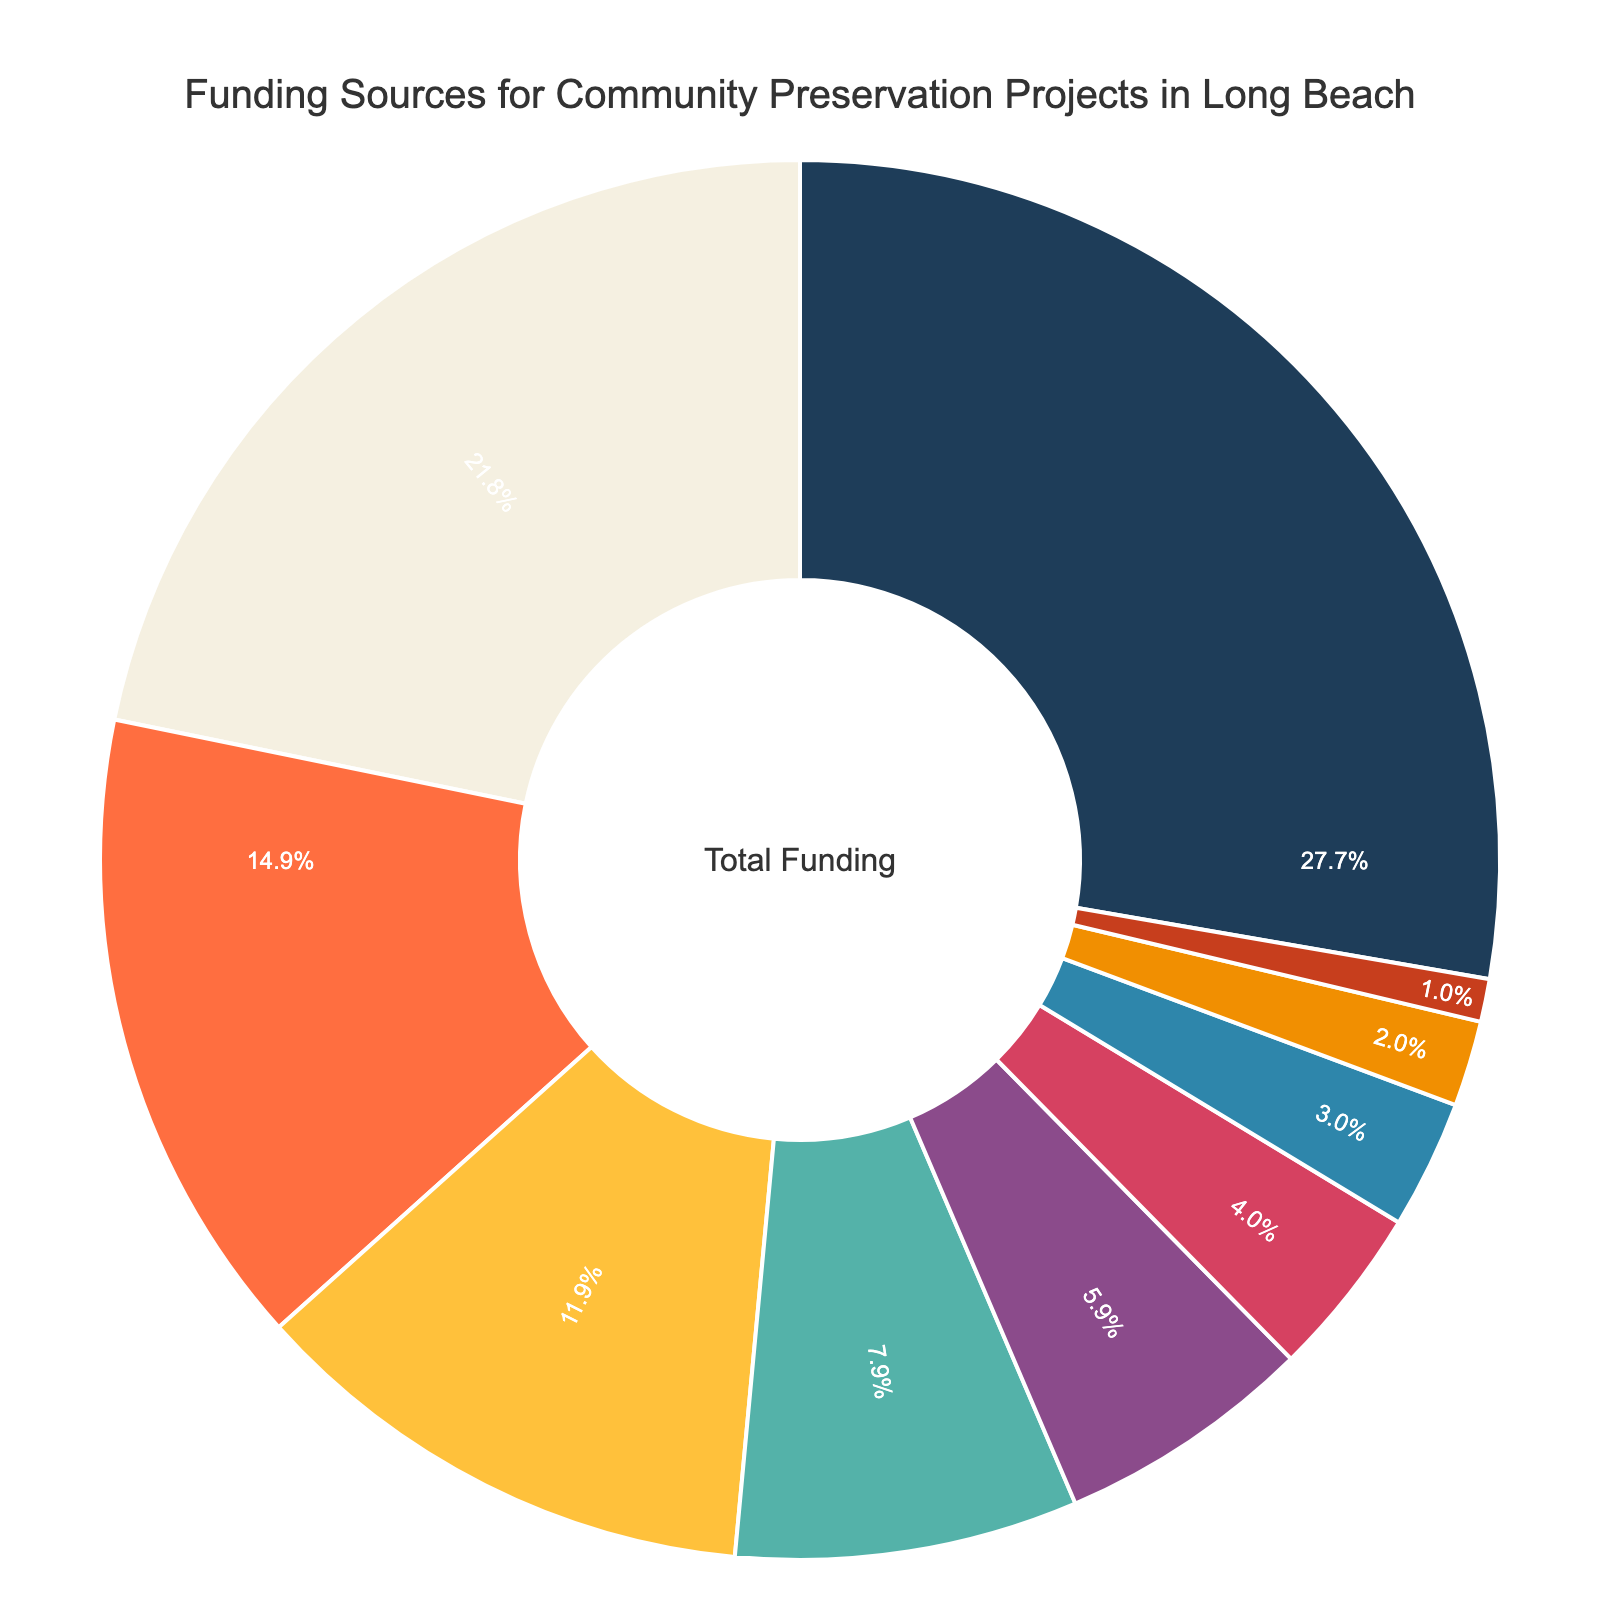Which category provides the largest portion of funding? The largest portion of the funding comes from the category with the highest percentage in the pie chart. "City Grants" has the largest portion at 28%.
Answer: City Grants What is the combined percentage of funding from Private Donations and Local Business Sponsorships? Add the percentages of Private Donations (12%) and Local Business Sponsorships (8%). The combined percentage is 12% + 8% = 20%.
Answer: 20% Which funding source contributes the least? The smallest portion of the funding is the category with the lowest percentage. "Real Estate Transfer Fees" has the smallest portion at 1%.
Answer: Real Estate Transfer Fees How much more funding do City Grants provide compared to Federal Historic Preservation Tax Credits? Subtract the percentage of Federal Historic Preservation Tax Credits (15%) from the percentage of City Grants (28%). The difference is 28% - 15% = 13%.
Answer: 13% What is the percentage contribution of crowdfunding campaigns? The percentage contribution of Crowdfunding Campaigns is directly given in the pie chart as 6%.
Answer: 6% How do State Historic Preservation Funds compare to Private Donations in terms of percentage? Compare the percentages: State Historic Preservation Funds (22%) vs. Private Donations (12%). State Historic Preservation Funds contribute a higher percentage.
Answer: State Historic Preservation Funds have a higher percentage If we exclude City Grants, what is the percentage contribution of the remaining categories combined? Subtract the percentage of City Grants (28%) from the total 100% and sum the remaining percentages: 100% - 28% = 72%.
Answer: 72% What is the difference between the highest and lowest funding sources? Subtract the percentage of the lowest funding source (Real Estate Transfer Fees: 1%) from the highest (City Grants: 28%), which gives 28% - 1% = 27%.
Answer: 27% Which categories contribute more than 10% to the overall funding? Identify the categories whose percentage is greater than 10%: City Grants (28%), State Historic Preservation Funds (22%), and Federal Historic Preservation Tax Credits (15%), Private Donations (12%).
Answer: City Grants, State Historic Preservation Funds, Federal Historic Preservation Tax Credits, Private Donations Is the contribution from Fundraising Events and Foundation Grants together greater than Local Business Sponsorships? Sum the percentages of Fundraising Events (3%) and Foundation Grants (2%) and compare with Local Business Sponsorships (8%). 3% + 2% = 5%, which is less than 8%.
Answer: No 